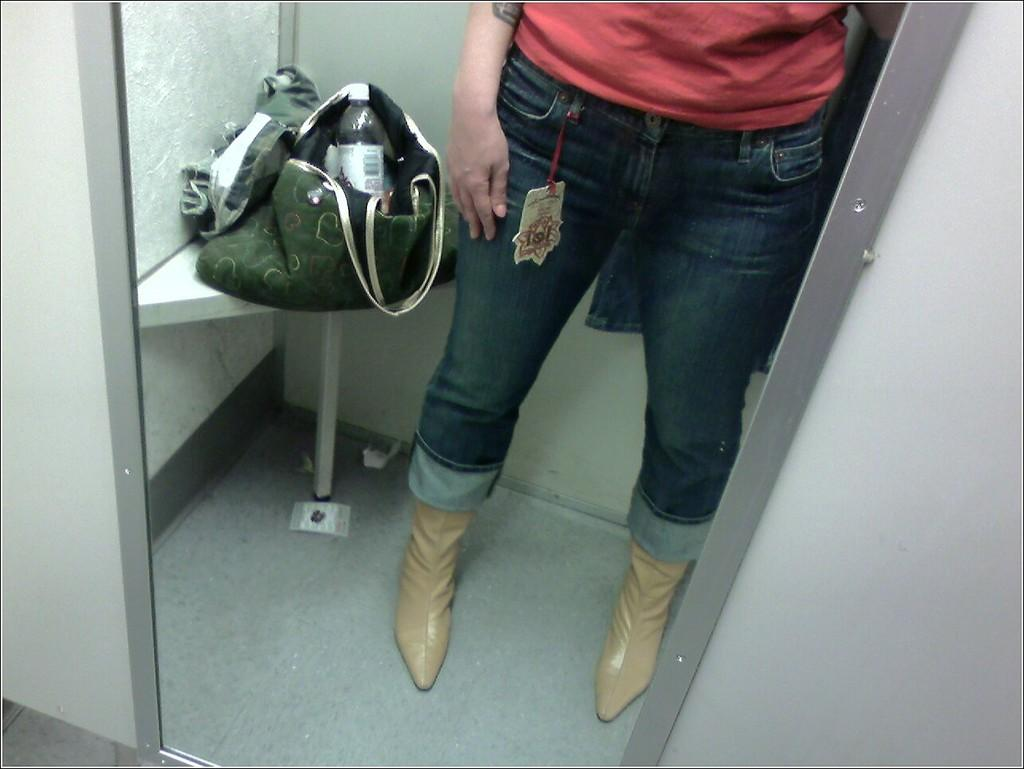What part of a person can be seen in the image? There are legs of a person in the image. What object is located beside the person's legs? There is a bag beside the person's legs. What is inside the bag? A water bottle is inside the bag. What caption is written on the water bottle in the image? There is no caption visible on the water bottle in the image. What rule is being enforced by the person in the image? There is no indication of any rule being enforced in the image. 